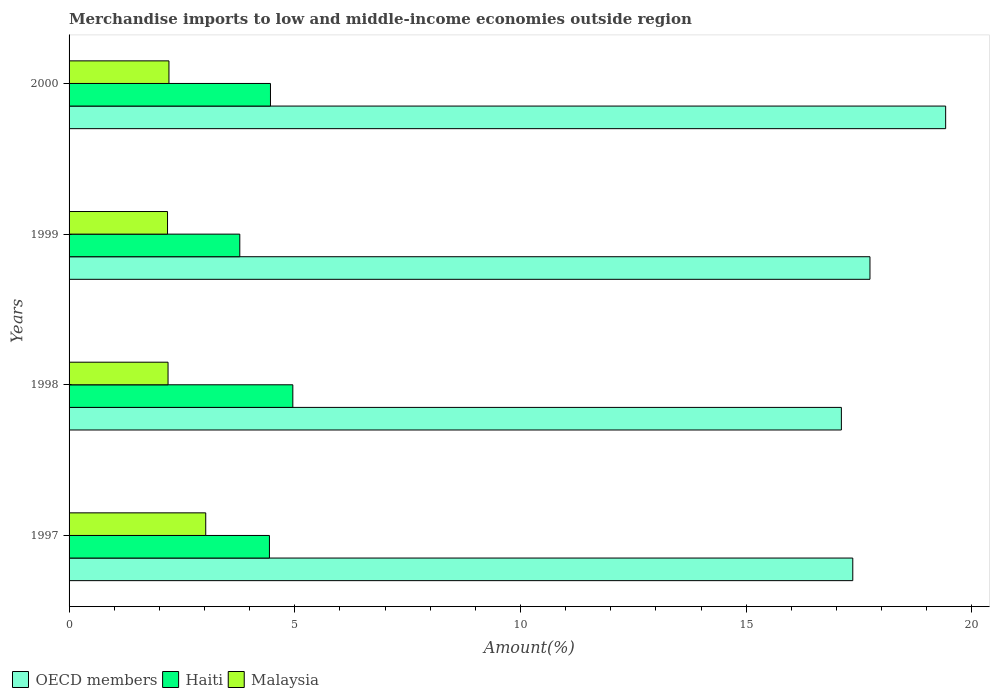How many different coloured bars are there?
Offer a terse response. 3. Are the number of bars on each tick of the Y-axis equal?
Provide a short and direct response. Yes. What is the percentage of amount earned from merchandise imports in OECD members in 1997?
Give a very brief answer. 17.36. Across all years, what is the maximum percentage of amount earned from merchandise imports in Haiti?
Give a very brief answer. 4.96. Across all years, what is the minimum percentage of amount earned from merchandise imports in OECD members?
Make the answer very short. 17.11. In which year was the percentage of amount earned from merchandise imports in OECD members maximum?
Give a very brief answer. 2000. In which year was the percentage of amount earned from merchandise imports in Haiti minimum?
Offer a very short reply. 1999. What is the total percentage of amount earned from merchandise imports in Haiti in the graph?
Offer a terse response. 17.64. What is the difference between the percentage of amount earned from merchandise imports in Malaysia in 1998 and that in 2000?
Keep it short and to the point. -0.02. What is the difference between the percentage of amount earned from merchandise imports in Malaysia in 2000 and the percentage of amount earned from merchandise imports in Haiti in 1999?
Give a very brief answer. -1.57. What is the average percentage of amount earned from merchandise imports in OECD members per year?
Provide a short and direct response. 17.91. In the year 1998, what is the difference between the percentage of amount earned from merchandise imports in Malaysia and percentage of amount earned from merchandise imports in OECD members?
Make the answer very short. -14.91. What is the ratio of the percentage of amount earned from merchandise imports in Malaysia in 1998 to that in 2000?
Offer a very short reply. 0.99. Is the percentage of amount earned from merchandise imports in Haiti in 1997 less than that in 2000?
Offer a very short reply. Yes. What is the difference between the highest and the second highest percentage of amount earned from merchandise imports in Malaysia?
Ensure brevity in your answer.  0.81. What is the difference between the highest and the lowest percentage of amount earned from merchandise imports in Haiti?
Your response must be concise. 1.17. What does the 1st bar from the top in 2000 represents?
Provide a succinct answer. Malaysia. What does the 3rd bar from the bottom in 1999 represents?
Your answer should be compact. Malaysia. Is it the case that in every year, the sum of the percentage of amount earned from merchandise imports in OECD members and percentage of amount earned from merchandise imports in Malaysia is greater than the percentage of amount earned from merchandise imports in Haiti?
Your response must be concise. Yes. How many bars are there?
Ensure brevity in your answer.  12. How many years are there in the graph?
Provide a short and direct response. 4. Are the values on the major ticks of X-axis written in scientific E-notation?
Your response must be concise. No. Does the graph contain grids?
Provide a short and direct response. No. Where does the legend appear in the graph?
Keep it short and to the point. Bottom left. What is the title of the graph?
Your answer should be compact. Merchandise imports to low and middle-income economies outside region. What is the label or title of the X-axis?
Provide a succinct answer. Amount(%). What is the label or title of the Y-axis?
Provide a short and direct response. Years. What is the Amount(%) of OECD members in 1997?
Provide a short and direct response. 17.36. What is the Amount(%) in Haiti in 1997?
Offer a terse response. 4.44. What is the Amount(%) in Malaysia in 1997?
Keep it short and to the point. 3.03. What is the Amount(%) in OECD members in 1998?
Your response must be concise. 17.11. What is the Amount(%) in Haiti in 1998?
Offer a very short reply. 4.96. What is the Amount(%) of Malaysia in 1998?
Your answer should be compact. 2.19. What is the Amount(%) in OECD members in 1999?
Your answer should be very brief. 17.74. What is the Amount(%) in Haiti in 1999?
Offer a terse response. 3.78. What is the Amount(%) in Malaysia in 1999?
Provide a succinct answer. 2.18. What is the Amount(%) in OECD members in 2000?
Your response must be concise. 19.42. What is the Amount(%) of Haiti in 2000?
Provide a short and direct response. 4.46. What is the Amount(%) in Malaysia in 2000?
Offer a terse response. 2.21. Across all years, what is the maximum Amount(%) of OECD members?
Your response must be concise. 19.42. Across all years, what is the maximum Amount(%) of Haiti?
Keep it short and to the point. 4.96. Across all years, what is the maximum Amount(%) in Malaysia?
Offer a very short reply. 3.03. Across all years, what is the minimum Amount(%) in OECD members?
Your response must be concise. 17.11. Across all years, what is the minimum Amount(%) of Haiti?
Your answer should be compact. 3.78. Across all years, what is the minimum Amount(%) in Malaysia?
Ensure brevity in your answer.  2.18. What is the total Amount(%) in OECD members in the graph?
Your answer should be very brief. 71.63. What is the total Amount(%) of Haiti in the graph?
Keep it short and to the point. 17.64. What is the total Amount(%) in Malaysia in the graph?
Ensure brevity in your answer.  9.61. What is the difference between the Amount(%) of OECD members in 1997 and that in 1998?
Make the answer very short. 0.25. What is the difference between the Amount(%) of Haiti in 1997 and that in 1998?
Provide a short and direct response. -0.52. What is the difference between the Amount(%) of Malaysia in 1997 and that in 1998?
Keep it short and to the point. 0.83. What is the difference between the Amount(%) of OECD members in 1997 and that in 1999?
Ensure brevity in your answer.  -0.38. What is the difference between the Amount(%) of Haiti in 1997 and that in 1999?
Give a very brief answer. 0.66. What is the difference between the Amount(%) in Malaysia in 1997 and that in 1999?
Offer a very short reply. 0.85. What is the difference between the Amount(%) of OECD members in 1997 and that in 2000?
Offer a very short reply. -2.06. What is the difference between the Amount(%) in Haiti in 1997 and that in 2000?
Make the answer very short. -0.02. What is the difference between the Amount(%) in Malaysia in 1997 and that in 2000?
Provide a short and direct response. 0.81. What is the difference between the Amount(%) in OECD members in 1998 and that in 1999?
Keep it short and to the point. -0.63. What is the difference between the Amount(%) in Haiti in 1998 and that in 1999?
Ensure brevity in your answer.  1.17. What is the difference between the Amount(%) in Malaysia in 1998 and that in 1999?
Make the answer very short. 0.01. What is the difference between the Amount(%) of OECD members in 1998 and that in 2000?
Your response must be concise. -2.31. What is the difference between the Amount(%) of Haiti in 1998 and that in 2000?
Make the answer very short. 0.5. What is the difference between the Amount(%) in Malaysia in 1998 and that in 2000?
Your answer should be very brief. -0.02. What is the difference between the Amount(%) in OECD members in 1999 and that in 2000?
Keep it short and to the point. -1.68. What is the difference between the Amount(%) in Haiti in 1999 and that in 2000?
Your answer should be very brief. -0.68. What is the difference between the Amount(%) of Malaysia in 1999 and that in 2000?
Your response must be concise. -0.03. What is the difference between the Amount(%) of OECD members in 1997 and the Amount(%) of Haiti in 1998?
Your answer should be compact. 12.4. What is the difference between the Amount(%) in OECD members in 1997 and the Amount(%) in Malaysia in 1998?
Make the answer very short. 15.17. What is the difference between the Amount(%) of Haiti in 1997 and the Amount(%) of Malaysia in 1998?
Ensure brevity in your answer.  2.25. What is the difference between the Amount(%) of OECD members in 1997 and the Amount(%) of Haiti in 1999?
Ensure brevity in your answer.  13.58. What is the difference between the Amount(%) of OECD members in 1997 and the Amount(%) of Malaysia in 1999?
Provide a short and direct response. 15.18. What is the difference between the Amount(%) in Haiti in 1997 and the Amount(%) in Malaysia in 1999?
Offer a very short reply. 2.26. What is the difference between the Amount(%) in OECD members in 1997 and the Amount(%) in Haiti in 2000?
Provide a succinct answer. 12.9. What is the difference between the Amount(%) in OECD members in 1997 and the Amount(%) in Malaysia in 2000?
Offer a terse response. 15.15. What is the difference between the Amount(%) in Haiti in 1997 and the Amount(%) in Malaysia in 2000?
Keep it short and to the point. 2.23. What is the difference between the Amount(%) of OECD members in 1998 and the Amount(%) of Haiti in 1999?
Provide a succinct answer. 13.33. What is the difference between the Amount(%) in OECD members in 1998 and the Amount(%) in Malaysia in 1999?
Provide a short and direct response. 14.93. What is the difference between the Amount(%) of Haiti in 1998 and the Amount(%) of Malaysia in 1999?
Make the answer very short. 2.78. What is the difference between the Amount(%) of OECD members in 1998 and the Amount(%) of Haiti in 2000?
Provide a short and direct response. 12.65. What is the difference between the Amount(%) in OECD members in 1998 and the Amount(%) in Malaysia in 2000?
Make the answer very short. 14.89. What is the difference between the Amount(%) of Haiti in 1998 and the Amount(%) of Malaysia in 2000?
Your response must be concise. 2.74. What is the difference between the Amount(%) in OECD members in 1999 and the Amount(%) in Haiti in 2000?
Provide a succinct answer. 13.28. What is the difference between the Amount(%) of OECD members in 1999 and the Amount(%) of Malaysia in 2000?
Provide a succinct answer. 15.53. What is the difference between the Amount(%) in Haiti in 1999 and the Amount(%) in Malaysia in 2000?
Your response must be concise. 1.57. What is the average Amount(%) in OECD members per year?
Keep it short and to the point. 17.91. What is the average Amount(%) in Haiti per year?
Make the answer very short. 4.41. What is the average Amount(%) of Malaysia per year?
Give a very brief answer. 2.4. In the year 1997, what is the difference between the Amount(%) in OECD members and Amount(%) in Haiti?
Your answer should be compact. 12.92. In the year 1997, what is the difference between the Amount(%) of OECD members and Amount(%) of Malaysia?
Offer a terse response. 14.33. In the year 1997, what is the difference between the Amount(%) in Haiti and Amount(%) in Malaysia?
Make the answer very short. 1.41. In the year 1998, what is the difference between the Amount(%) of OECD members and Amount(%) of Haiti?
Provide a succinct answer. 12.15. In the year 1998, what is the difference between the Amount(%) in OECD members and Amount(%) in Malaysia?
Ensure brevity in your answer.  14.91. In the year 1998, what is the difference between the Amount(%) of Haiti and Amount(%) of Malaysia?
Provide a short and direct response. 2.76. In the year 1999, what is the difference between the Amount(%) of OECD members and Amount(%) of Haiti?
Your answer should be compact. 13.96. In the year 1999, what is the difference between the Amount(%) of OECD members and Amount(%) of Malaysia?
Keep it short and to the point. 15.56. In the year 1999, what is the difference between the Amount(%) in Haiti and Amount(%) in Malaysia?
Offer a terse response. 1.6. In the year 2000, what is the difference between the Amount(%) in OECD members and Amount(%) in Haiti?
Your answer should be very brief. 14.96. In the year 2000, what is the difference between the Amount(%) in OECD members and Amount(%) in Malaysia?
Provide a succinct answer. 17.2. In the year 2000, what is the difference between the Amount(%) of Haiti and Amount(%) of Malaysia?
Offer a terse response. 2.25. What is the ratio of the Amount(%) in OECD members in 1997 to that in 1998?
Offer a terse response. 1.01. What is the ratio of the Amount(%) of Haiti in 1997 to that in 1998?
Provide a succinct answer. 0.9. What is the ratio of the Amount(%) of Malaysia in 1997 to that in 1998?
Your answer should be compact. 1.38. What is the ratio of the Amount(%) in OECD members in 1997 to that in 1999?
Offer a very short reply. 0.98. What is the ratio of the Amount(%) in Haiti in 1997 to that in 1999?
Give a very brief answer. 1.17. What is the ratio of the Amount(%) of Malaysia in 1997 to that in 1999?
Give a very brief answer. 1.39. What is the ratio of the Amount(%) of OECD members in 1997 to that in 2000?
Your response must be concise. 0.89. What is the ratio of the Amount(%) of Malaysia in 1997 to that in 2000?
Provide a succinct answer. 1.37. What is the ratio of the Amount(%) in Haiti in 1998 to that in 1999?
Offer a very short reply. 1.31. What is the ratio of the Amount(%) in OECD members in 1998 to that in 2000?
Your response must be concise. 0.88. What is the ratio of the Amount(%) in Haiti in 1998 to that in 2000?
Your response must be concise. 1.11. What is the ratio of the Amount(%) of Malaysia in 1998 to that in 2000?
Your answer should be compact. 0.99. What is the ratio of the Amount(%) of OECD members in 1999 to that in 2000?
Offer a very short reply. 0.91. What is the ratio of the Amount(%) of Haiti in 1999 to that in 2000?
Give a very brief answer. 0.85. What is the ratio of the Amount(%) in Malaysia in 1999 to that in 2000?
Provide a short and direct response. 0.99. What is the difference between the highest and the second highest Amount(%) of OECD members?
Provide a succinct answer. 1.68. What is the difference between the highest and the second highest Amount(%) in Haiti?
Offer a very short reply. 0.5. What is the difference between the highest and the second highest Amount(%) in Malaysia?
Your answer should be compact. 0.81. What is the difference between the highest and the lowest Amount(%) of OECD members?
Provide a short and direct response. 2.31. What is the difference between the highest and the lowest Amount(%) in Haiti?
Give a very brief answer. 1.17. What is the difference between the highest and the lowest Amount(%) in Malaysia?
Your answer should be compact. 0.85. 